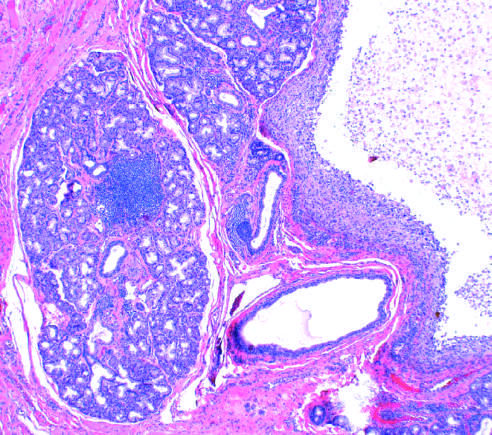what are seen on the left?
Answer the question using a single word or phrase. The normal gland acini 